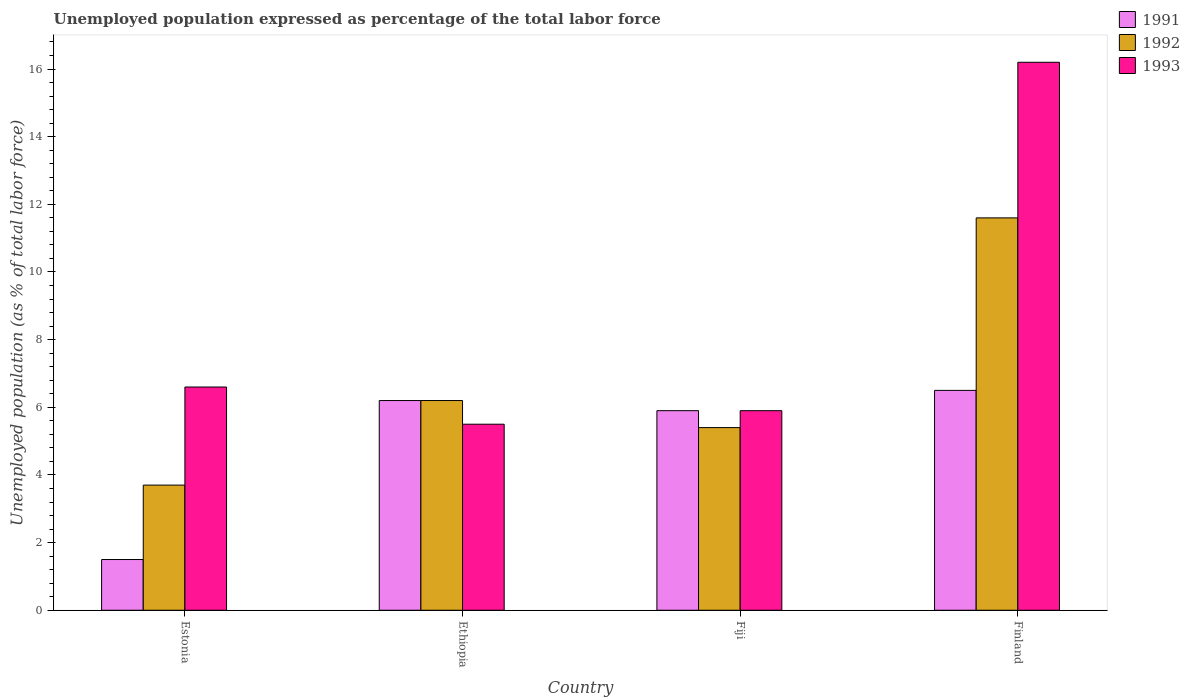How many different coloured bars are there?
Ensure brevity in your answer.  3. Are the number of bars per tick equal to the number of legend labels?
Offer a terse response. Yes. How many bars are there on the 2nd tick from the left?
Your answer should be very brief. 3. What is the label of the 2nd group of bars from the left?
Keep it short and to the point. Ethiopia. In how many cases, is the number of bars for a given country not equal to the number of legend labels?
Your answer should be compact. 0. Across all countries, what is the maximum unemployment in in 1992?
Keep it short and to the point. 11.6. Across all countries, what is the minimum unemployment in in 1992?
Provide a short and direct response. 3.7. In which country was the unemployment in in 1991 maximum?
Offer a terse response. Finland. In which country was the unemployment in in 1992 minimum?
Your answer should be compact. Estonia. What is the total unemployment in in 1992 in the graph?
Provide a succinct answer. 26.9. What is the difference between the unemployment in in 1991 in Ethiopia and that in Finland?
Your answer should be compact. -0.3. What is the difference between the unemployment in in 1991 in Fiji and the unemployment in in 1992 in Estonia?
Your answer should be compact. 2.2. What is the average unemployment in in 1992 per country?
Your answer should be very brief. 6.73. What is the difference between the unemployment in of/in 1991 and unemployment in of/in 1992 in Estonia?
Give a very brief answer. -2.2. What is the ratio of the unemployment in in 1993 in Ethiopia to that in Fiji?
Ensure brevity in your answer.  0.93. What is the difference between the highest and the second highest unemployment in in 1992?
Your response must be concise. 6.2. What is the difference between the highest and the lowest unemployment in in 1993?
Provide a short and direct response. 10.7. What does the 2nd bar from the left in Estonia represents?
Offer a very short reply. 1992. What does the 1st bar from the right in Finland represents?
Offer a terse response. 1993. Are all the bars in the graph horizontal?
Make the answer very short. No. How many countries are there in the graph?
Ensure brevity in your answer.  4. Does the graph contain grids?
Your answer should be very brief. No. How many legend labels are there?
Keep it short and to the point. 3. What is the title of the graph?
Offer a very short reply. Unemployed population expressed as percentage of the total labor force. What is the label or title of the Y-axis?
Make the answer very short. Unemployed population (as % of total labor force). What is the Unemployed population (as % of total labor force) in 1992 in Estonia?
Provide a short and direct response. 3.7. What is the Unemployed population (as % of total labor force) in 1993 in Estonia?
Provide a short and direct response. 6.6. What is the Unemployed population (as % of total labor force) in 1991 in Ethiopia?
Your answer should be compact. 6.2. What is the Unemployed population (as % of total labor force) of 1992 in Ethiopia?
Ensure brevity in your answer.  6.2. What is the Unemployed population (as % of total labor force) in 1991 in Fiji?
Your answer should be very brief. 5.9. What is the Unemployed population (as % of total labor force) in 1992 in Fiji?
Your response must be concise. 5.4. What is the Unemployed population (as % of total labor force) in 1993 in Fiji?
Offer a very short reply. 5.9. What is the Unemployed population (as % of total labor force) in 1991 in Finland?
Offer a terse response. 6.5. What is the Unemployed population (as % of total labor force) in 1992 in Finland?
Your response must be concise. 11.6. What is the Unemployed population (as % of total labor force) of 1993 in Finland?
Your response must be concise. 16.2. Across all countries, what is the maximum Unemployed population (as % of total labor force) of 1992?
Provide a succinct answer. 11.6. Across all countries, what is the maximum Unemployed population (as % of total labor force) in 1993?
Offer a very short reply. 16.2. Across all countries, what is the minimum Unemployed population (as % of total labor force) in 1992?
Your response must be concise. 3.7. What is the total Unemployed population (as % of total labor force) of 1991 in the graph?
Your answer should be very brief. 20.1. What is the total Unemployed population (as % of total labor force) in 1992 in the graph?
Make the answer very short. 26.9. What is the total Unemployed population (as % of total labor force) in 1993 in the graph?
Provide a short and direct response. 34.2. What is the difference between the Unemployed population (as % of total labor force) of 1992 in Estonia and that in Fiji?
Your answer should be compact. -1.7. What is the difference between the Unemployed population (as % of total labor force) in 1991 in Estonia and that in Finland?
Offer a very short reply. -5. What is the difference between the Unemployed population (as % of total labor force) of 1993 in Estonia and that in Finland?
Make the answer very short. -9.6. What is the difference between the Unemployed population (as % of total labor force) of 1991 in Ethiopia and that in Fiji?
Your response must be concise. 0.3. What is the difference between the Unemployed population (as % of total labor force) in 1993 in Ethiopia and that in Finland?
Provide a short and direct response. -10.7. What is the difference between the Unemployed population (as % of total labor force) of 1991 in Fiji and that in Finland?
Provide a short and direct response. -0.6. What is the difference between the Unemployed population (as % of total labor force) of 1992 in Fiji and that in Finland?
Provide a succinct answer. -6.2. What is the difference between the Unemployed population (as % of total labor force) in 1991 in Estonia and the Unemployed population (as % of total labor force) in 1992 in Ethiopia?
Your response must be concise. -4.7. What is the difference between the Unemployed population (as % of total labor force) of 1991 in Estonia and the Unemployed population (as % of total labor force) of 1993 in Ethiopia?
Provide a short and direct response. -4. What is the difference between the Unemployed population (as % of total labor force) in 1992 in Estonia and the Unemployed population (as % of total labor force) in 1993 in Ethiopia?
Your answer should be compact. -1.8. What is the difference between the Unemployed population (as % of total labor force) in 1991 in Estonia and the Unemployed population (as % of total labor force) in 1993 in Fiji?
Make the answer very short. -4.4. What is the difference between the Unemployed population (as % of total labor force) of 1991 in Estonia and the Unemployed population (as % of total labor force) of 1993 in Finland?
Offer a very short reply. -14.7. What is the difference between the Unemployed population (as % of total labor force) in 1992 in Estonia and the Unemployed population (as % of total labor force) in 1993 in Finland?
Provide a short and direct response. -12.5. What is the difference between the Unemployed population (as % of total labor force) of 1991 in Ethiopia and the Unemployed population (as % of total labor force) of 1993 in Fiji?
Give a very brief answer. 0.3. What is the difference between the Unemployed population (as % of total labor force) in 1992 in Ethiopia and the Unemployed population (as % of total labor force) in 1993 in Fiji?
Your answer should be very brief. 0.3. What is the difference between the Unemployed population (as % of total labor force) of 1991 in Ethiopia and the Unemployed population (as % of total labor force) of 1992 in Finland?
Provide a succinct answer. -5.4. What is the difference between the Unemployed population (as % of total labor force) in 1992 in Ethiopia and the Unemployed population (as % of total labor force) in 1993 in Finland?
Give a very brief answer. -10. What is the average Unemployed population (as % of total labor force) of 1991 per country?
Provide a short and direct response. 5.03. What is the average Unemployed population (as % of total labor force) of 1992 per country?
Your response must be concise. 6.72. What is the average Unemployed population (as % of total labor force) of 1993 per country?
Make the answer very short. 8.55. What is the difference between the Unemployed population (as % of total labor force) of 1991 and Unemployed population (as % of total labor force) of 1992 in Estonia?
Your answer should be compact. -2.2. What is the difference between the Unemployed population (as % of total labor force) of 1991 and Unemployed population (as % of total labor force) of 1993 in Estonia?
Make the answer very short. -5.1. What is the difference between the Unemployed population (as % of total labor force) of 1992 and Unemployed population (as % of total labor force) of 1993 in Estonia?
Offer a very short reply. -2.9. What is the difference between the Unemployed population (as % of total labor force) of 1991 and Unemployed population (as % of total labor force) of 1993 in Fiji?
Keep it short and to the point. 0. What is the difference between the Unemployed population (as % of total labor force) of 1991 and Unemployed population (as % of total labor force) of 1992 in Finland?
Your response must be concise. -5.1. What is the ratio of the Unemployed population (as % of total labor force) in 1991 in Estonia to that in Ethiopia?
Offer a terse response. 0.24. What is the ratio of the Unemployed population (as % of total labor force) in 1992 in Estonia to that in Ethiopia?
Keep it short and to the point. 0.6. What is the ratio of the Unemployed population (as % of total labor force) in 1993 in Estonia to that in Ethiopia?
Offer a terse response. 1.2. What is the ratio of the Unemployed population (as % of total labor force) of 1991 in Estonia to that in Fiji?
Your response must be concise. 0.25. What is the ratio of the Unemployed population (as % of total labor force) of 1992 in Estonia to that in Fiji?
Provide a succinct answer. 0.69. What is the ratio of the Unemployed population (as % of total labor force) in 1993 in Estonia to that in Fiji?
Your answer should be very brief. 1.12. What is the ratio of the Unemployed population (as % of total labor force) in 1991 in Estonia to that in Finland?
Provide a succinct answer. 0.23. What is the ratio of the Unemployed population (as % of total labor force) in 1992 in Estonia to that in Finland?
Your answer should be compact. 0.32. What is the ratio of the Unemployed population (as % of total labor force) in 1993 in Estonia to that in Finland?
Your answer should be very brief. 0.41. What is the ratio of the Unemployed population (as % of total labor force) of 1991 in Ethiopia to that in Fiji?
Provide a succinct answer. 1.05. What is the ratio of the Unemployed population (as % of total labor force) of 1992 in Ethiopia to that in Fiji?
Keep it short and to the point. 1.15. What is the ratio of the Unemployed population (as % of total labor force) in 1993 in Ethiopia to that in Fiji?
Your answer should be very brief. 0.93. What is the ratio of the Unemployed population (as % of total labor force) of 1991 in Ethiopia to that in Finland?
Your answer should be very brief. 0.95. What is the ratio of the Unemployed population (as % of total labor force) of 1992 in Ethiopia to that in Finland?
Keep it short and to the point. 0.53. What is the ratio of the Unemployed population (as % of total labor force) of 1993 in Ethiopia to that in Finland?
Offer a very short reply. 0.34. What is the ratio of the Unemployed population (as % of total labor force) of 1991 in Fiji to that in Finland?
Keep it short and to the point. 0.91. What is the ratio of the Unemployed population (as % of total labor force) in 1992 in Fiji to that in Finland?
Provide a short and direct response. 0.47. What is the ratio of the Unemployed population (as % of total labor force) in 1993 in Fiji to that in Finland?
Give a very brief answer. 0.36. What is the difference between the highest and the lowest Unemployed population (as % of total labor force) of 1992?
Give a very brief answer. 7.9. What is the difference between the highest and the lowest Unemployed population (as % of total labor force) of 1993?
Make the answer very short. 10.7. 